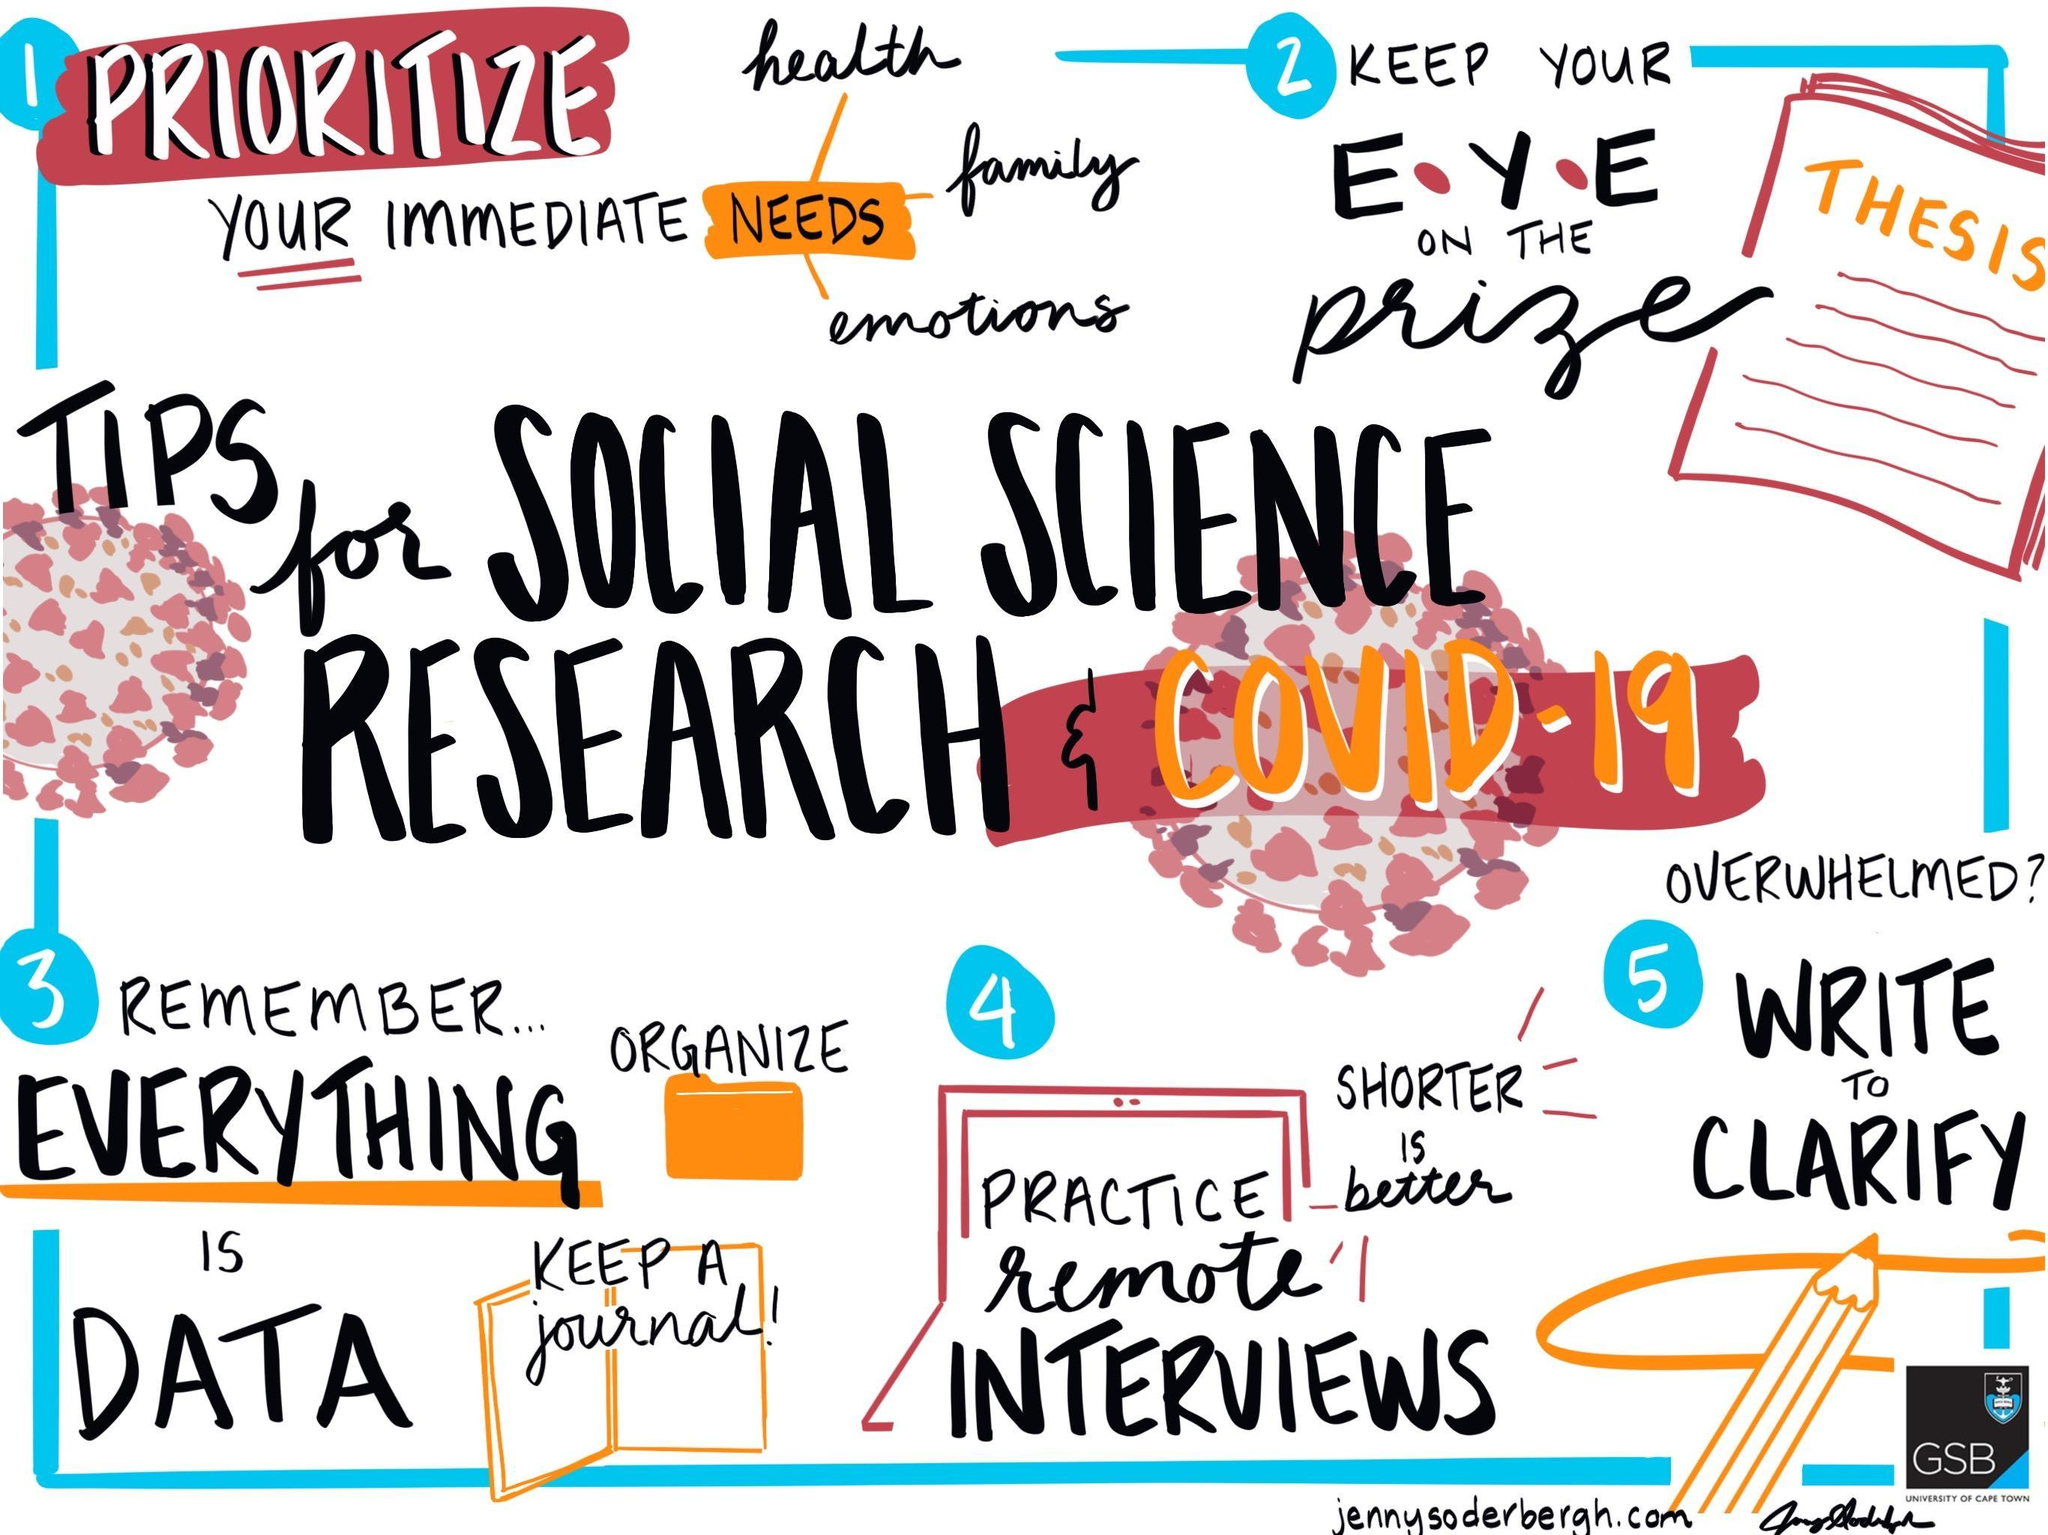What is the fifth tip given in the image?
Answer the question with a short phrase. Write to clarify What is the fourth tip given in the image? Practice remote interviews 